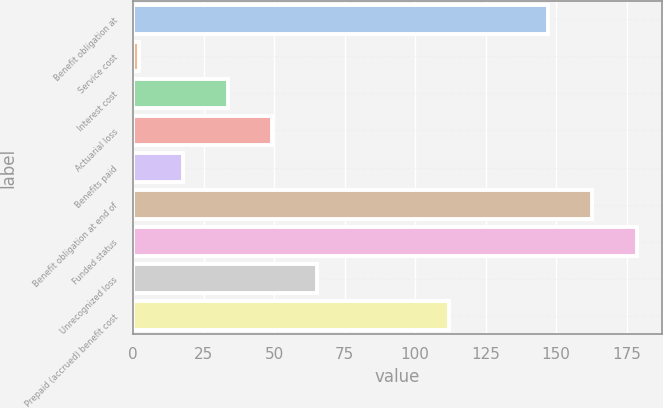<chart> <loc_0><loc_0><loc_500><loc_500><bar_chart><fcel>Benefit obligation at<fcel>Service cost<fcel>Interest cost<fcel>Actuarial loss<fcel>Benefits paid<fcel>Benefit obligation at end of<fcel>Funded status<fcel>Unrecognized loss<fcel>Prepaid (accrued) benefit cost<nl><fcel>147<fcel>2<fcel>33.56<fcel>49.34<fcel>17.78<fcel>162.78<fcel>178.56<fcel>65.12<fcel>112<nl></chart> 